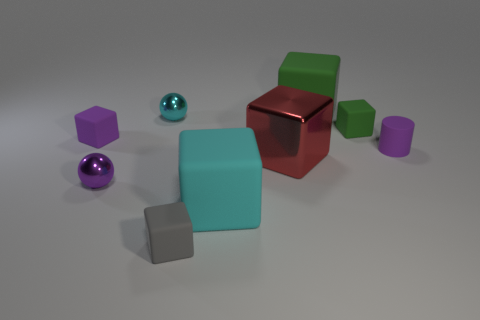How big is the cyan cube?
Offer a terse response. Large. What number of tiny objects are either cylinders or cyan metal spheres?
Ensure brevity in your answer.  2. There is a purple cube; is it the same size as the cyan thing in front of the small purple metal ball?
Offer a very short reply. No. How many tiny red blocks are there?
Make the answer very short. 0. How many yellow things are either large spheres or small cubes?
Provide a succinct answer. 0. Does the tiny ball that is behind the small green cube have the same material as the purple sphere?
Provide a short and direct response. Yes. What number of other objects are the same material as the gray thing?
Ensure brevity in your answer.  5. What is the cyan cube made of?
Make the answer very short. Rubber. How big is the cyan thing to the right of the small gray thing?
Ensure brevity in your answer.  Large. There is a big cube behind the tiny purple block; what number of cylinders are on the right side of it?
Offer a very short reply. 1. 